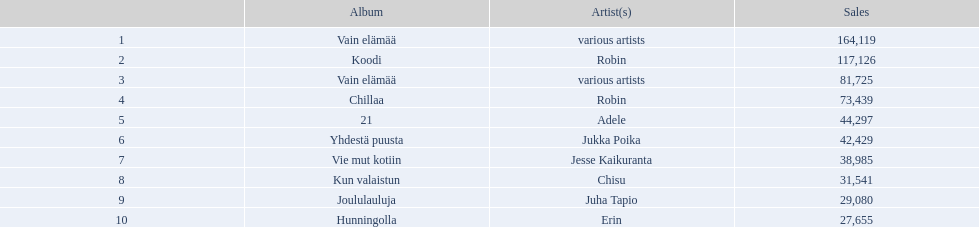Between adele and chisu, who has the most sales? Adele. 